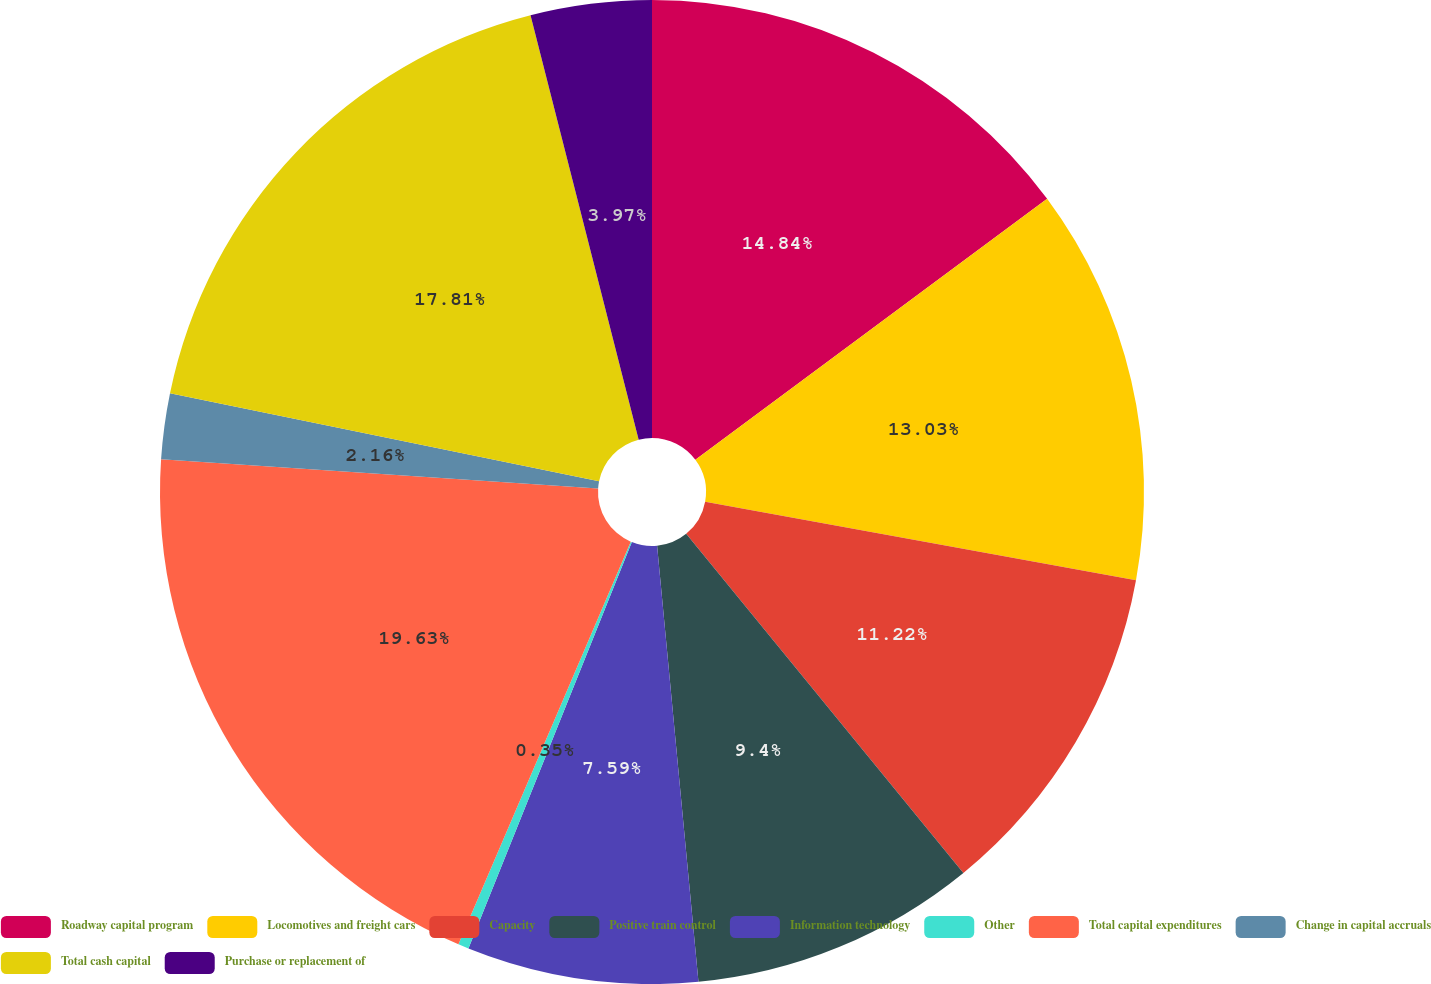<chart> <loc_0><loc_0><loc_500><loc_500><pie_chart><fcel>Roadway capital program<fcel>Locomotives and freight cars<fcel>Capacity<fcel>Positive train control<fcel>Information technology<fcel>Other<fcel>Total capital expenditures<fcel>Change in capital accruals<fcel>Total cash capital<fcel>Purchase or replacement of<nl><fcel>14.84%<fcel>13.03%<fcel>11.22%<fcel>9.4%<fcel>7.59%<fcel>0.35%<fcel>19.62%<fcel>2.16%<fcel>17.81%<fcel>3.97%<nl></chart> 